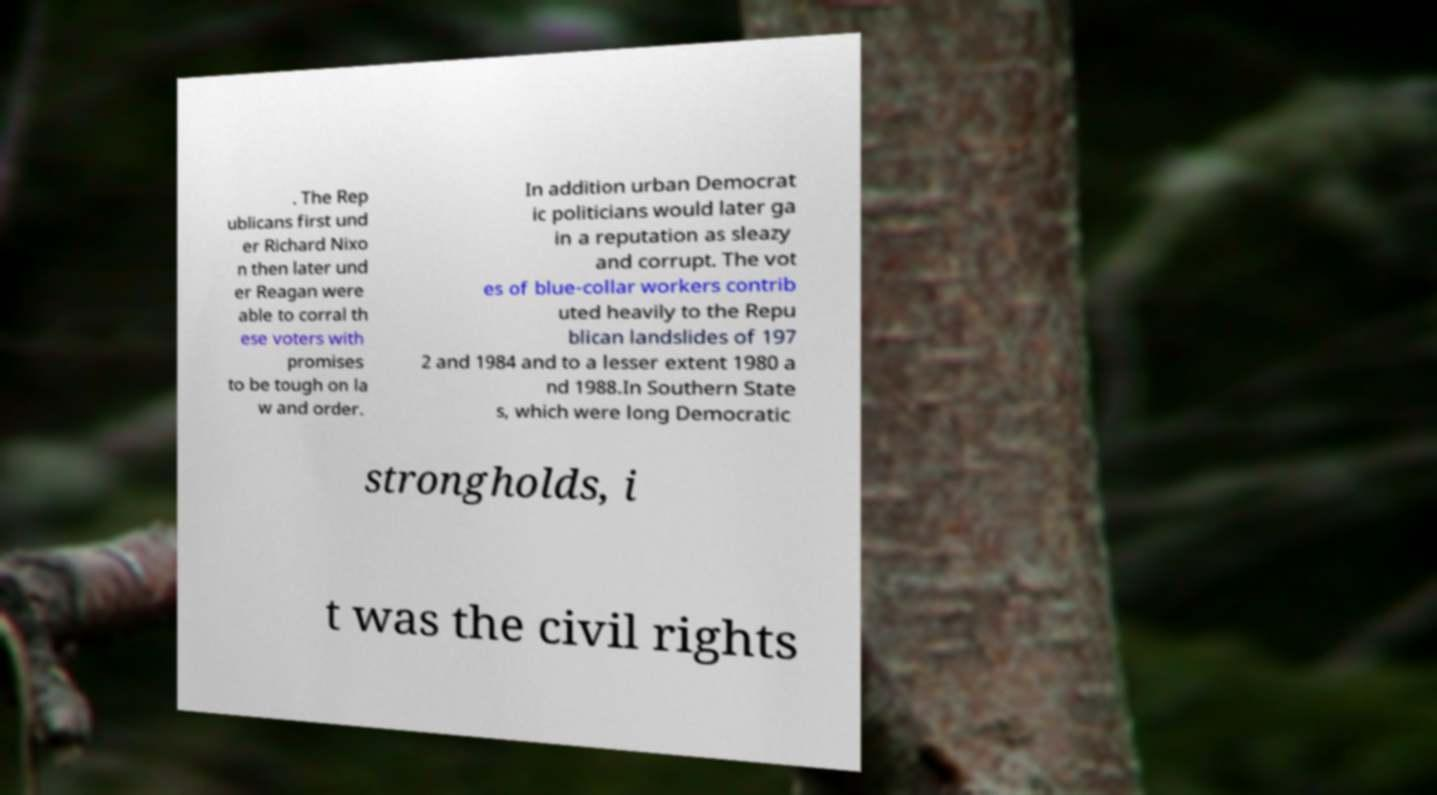For documentation purposes, I need the text within this image transcribed. Could you provide that? . The Rep ublicans first und er Richard Nixo n then later und er Reagan were able to corral th ese voters with promises to be tough on la w and order. In addition urban Democrat ic politicians would later ga in a reputation as sleazy and corrupt. The vot es of blue-collar workers contrib uted heavily to the Repu blican landslides of 197 2 and 1984 and to a lesser extent 1980 a nd 1988.In Southern State s, which were long Democratic strongholds, i t was the civil rights 